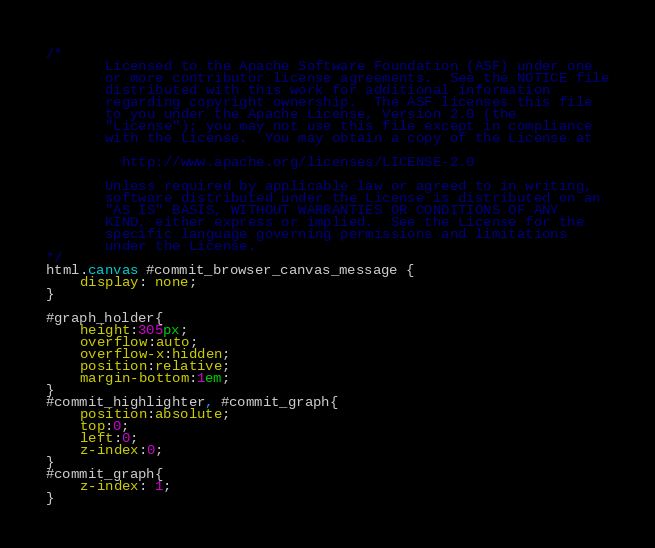<code> <loc_0><loc_0><loc_500><loc_500><_CSS_>/*
       Licensed to the Apache Software Foundation (ASF) under one
       or more contributor license agreements.  See the NOTICE file
       distributed with this work for additional information
       regarding copyright ownership.  The ASF licenses this file
       to you under the Apache License, Version 2.0 (the
       "License"); you may not use this file except in compliance
       with the License.  You may obtain a copy of the License at

         http://www.apache.org/licenses/LICENSE-2.0

       Unless required by applicable law or agreed to in writing,
       software distributed under the License is distributed on an
       "AS IS" BASIS, WITHOUT WARRANTIES OR CONDITIONS OF ANY
       KIND, either express or implied.  See the License for the
       specific language governing permissions and limitations
       under the License.
*/
html.canvas #commit_browser_canvas_message {
    display: none;
}

#graph_holder{
    height:305px;
    overflow:auto;
    overflow-x:hidden;
    position:relative;
    margin-bottom:1em;
}
#commit_highlighter, #commit_graph{
    position:absolute;
    top:0;
    left:0;
    z-index:0;
}
#commit_graph{
    z-index: 1;
}
</code> 